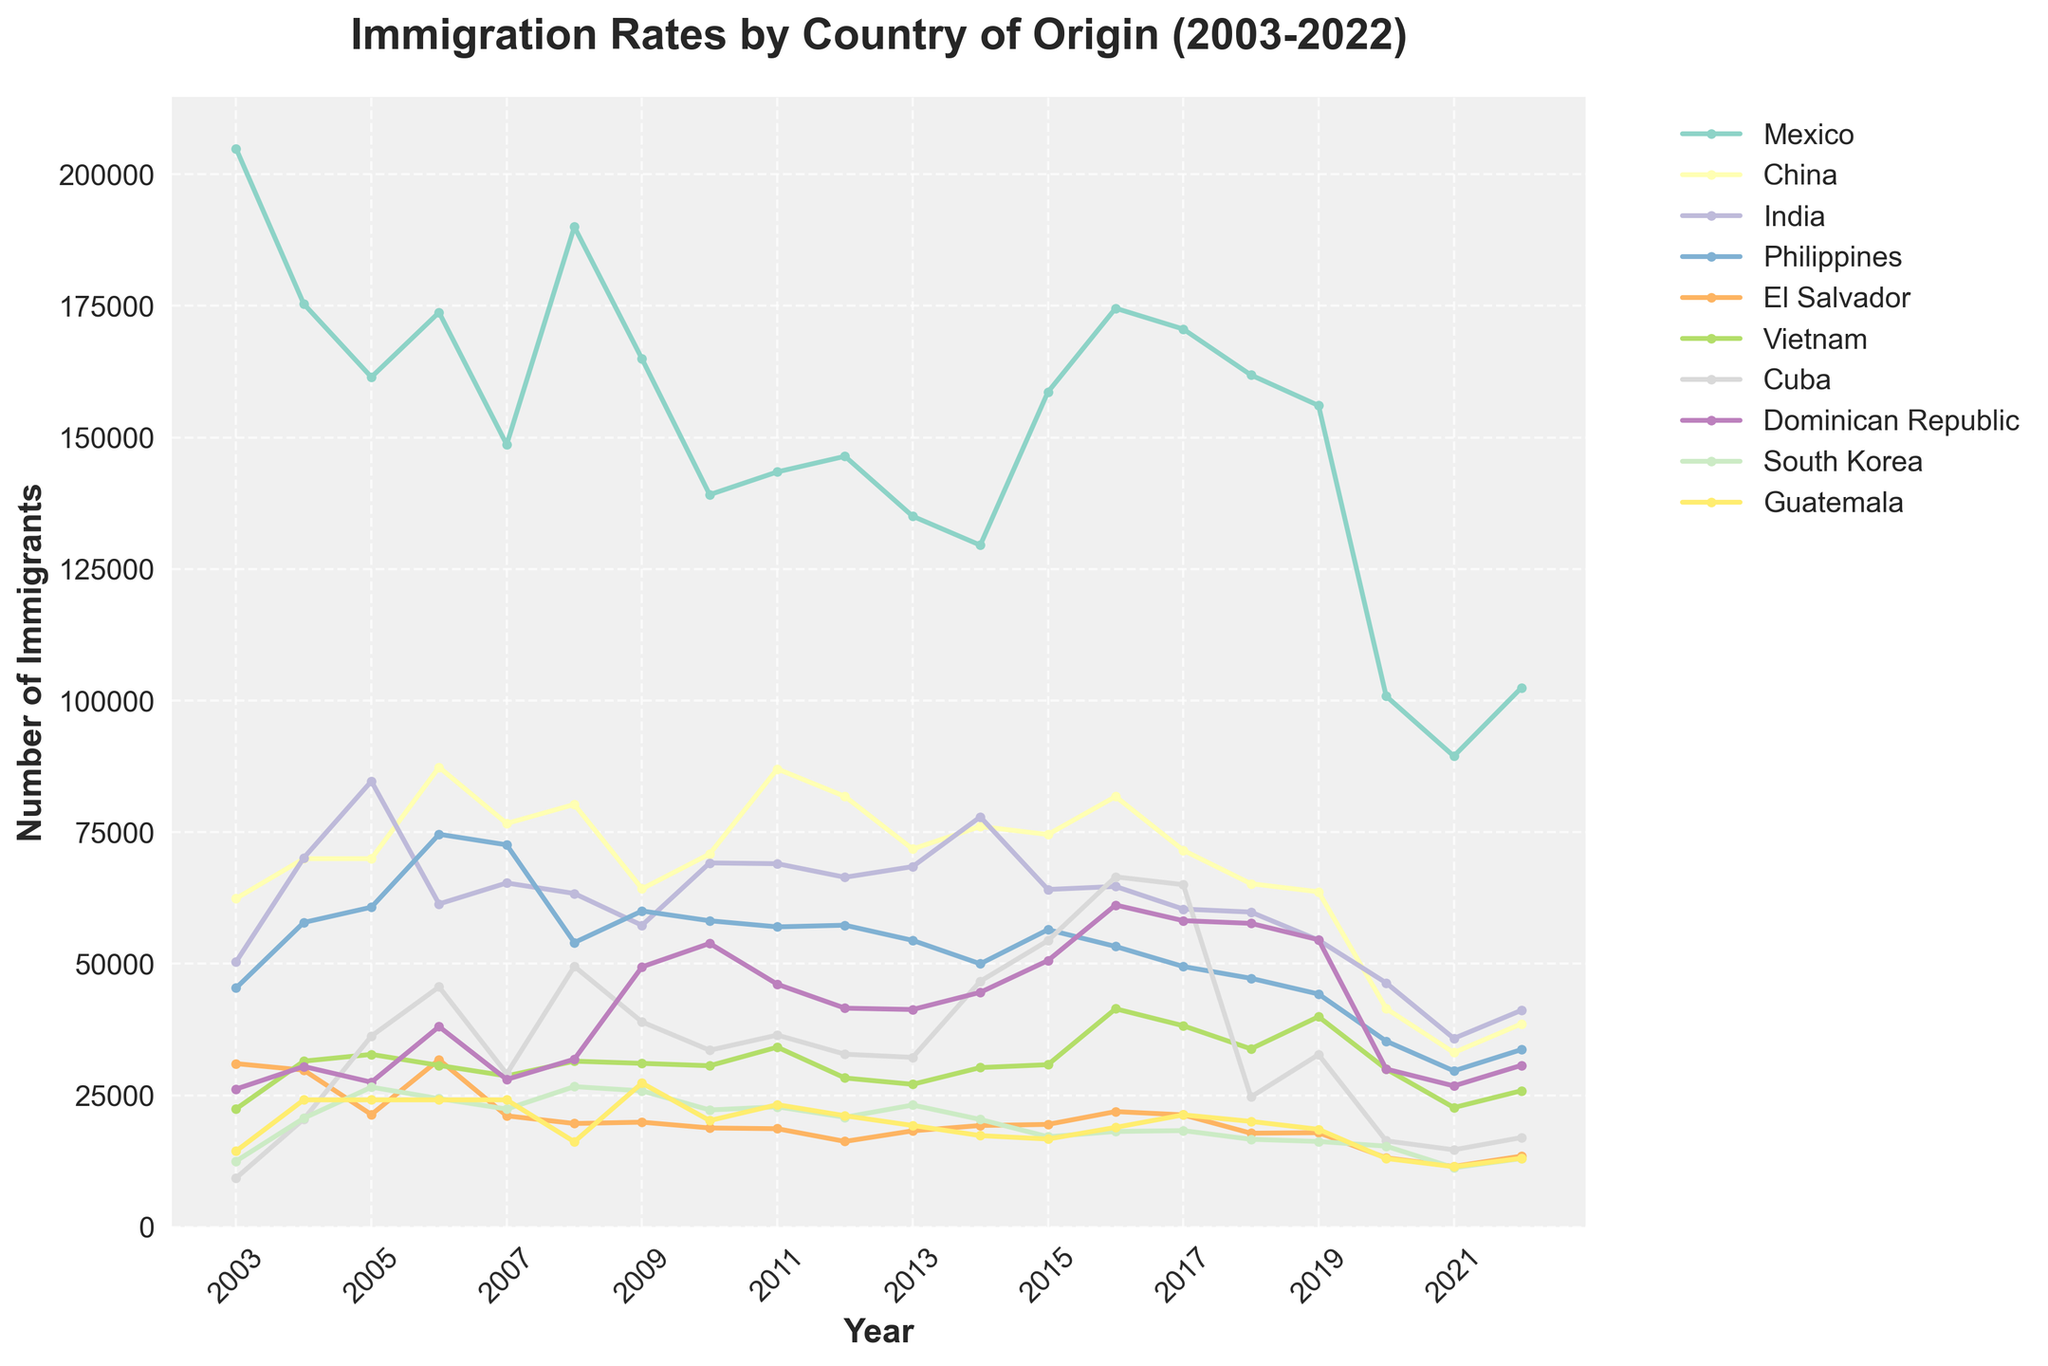Which country had the highest number of immigrants in 2022? First, locate the year 2022 on the x-axis. Then, look at the corresponding y-values for each country and identify the highest point.
Answer: Mexico How did the immigration numbers from Mexico change from 2003 to 2022? Locate the points for Mexico in the years 2003 and 2022. Observe the height difference between these two points. The number decreased from 204,875 in 2003 to 102,450 in 2022.
Answer: Decreased Which two countries showed the largest decrease in immigration rates from 2019 to 2020? Locate the years 2019 and 2020 on the x-axis. Compare the height difference of the points for each country between these two years. The largest decreases are for Mexico and the Dominican Republic.
Answer: Mexico and Dominican Republic Which country showed the most stable immigration rate over the entire period? Compare the lines for each country, looking for the one with the least variation or smallest fluctuations from year to year. India shows relatively stable immigration rates compared to others.
Answer: India In which year did immigration from Cuba show the highest rate, and how many immigrants were recorded? Follow the line representing Cuba and identify the highest point along the y-axis. The peak year is 2016 with 66,516 immigrants.
Answer: 2016, 66,516 What was the combined number of immigrants from Guatemala, El Salvador, and Vietnam in 2021? Locate the points for Guatemala (11,455), El Salvador (11,506), and Vietnam (22,683) in 2021 and sum these values. The sum is 45,644.
Answer: 45,644 Which country experienced the steepest decline in immigration in 2020 compared to the previous year? Look for the country line that shows the sharpest drop between 2019 and 2020 on the graph. Mexico shows the steepest decline from 156,052 to 100,835.
Answer: Mexico How does the trend of South Korean immigration compare to that of Filipino immigration from 2003 to 2022? Observe the lines for South Korea and the Philippines. South Korea shows a consistent decline while the Philippines has fluctuations but a generally downward trend.
Answer: Consistent decline vs fluctuating decline During which years did China experience a higher number of immigrants compared to India? Compare the lines for China and India year by year. In 2006, 2011, 2016, 2019, and 2020, China's immigrant numbers were higher than India's.
Answer: 2006, 2011, 2016, 2019, 2020 Which countries had immigration numbers lower than 20,000 in 2021? Locate 2021 on the x-axis and check the y-values for each country. El Salvador (11,506) and Guatemala (11,455) had immigration numbers lower than 20,000.
Answer: El Salvador and Guatemala 